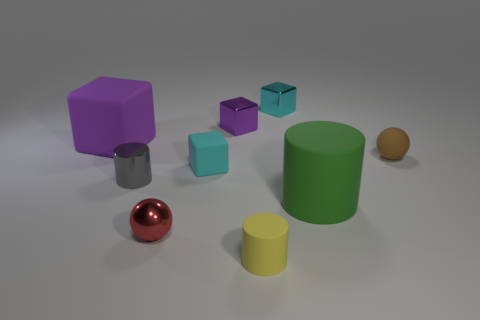Subtract 1 blocks. How many blocks are left? 3 Subtract all blue cylinders. Subtract all brown balls. How many cylinders are left? 3 Subtract all cubes. How many objects are left? 5 Add 2 yellow cylinders. How many yellow cylinders are left? 3 Add 5 green things. How many green things exist? 6 Subtract 1 green cylinders. How many objects are left? 8 Subtract all red shiny things. Subtract all purple rubber blocks. How many objects are left? 7 